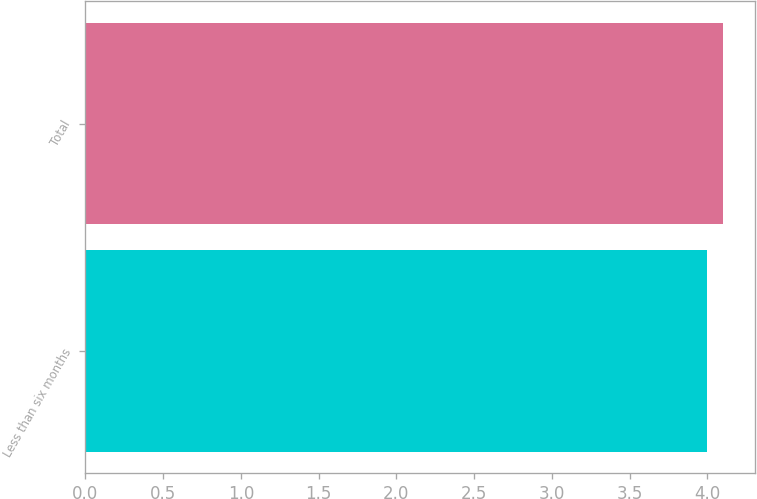Convert chart to OTSL. <chart><loc_0><loc_0><loc_500><loc_500><bar_chart><fcel>Less than six months<fcel>Total<nl><fcel>4<fcel>4.1<nl></chart> 